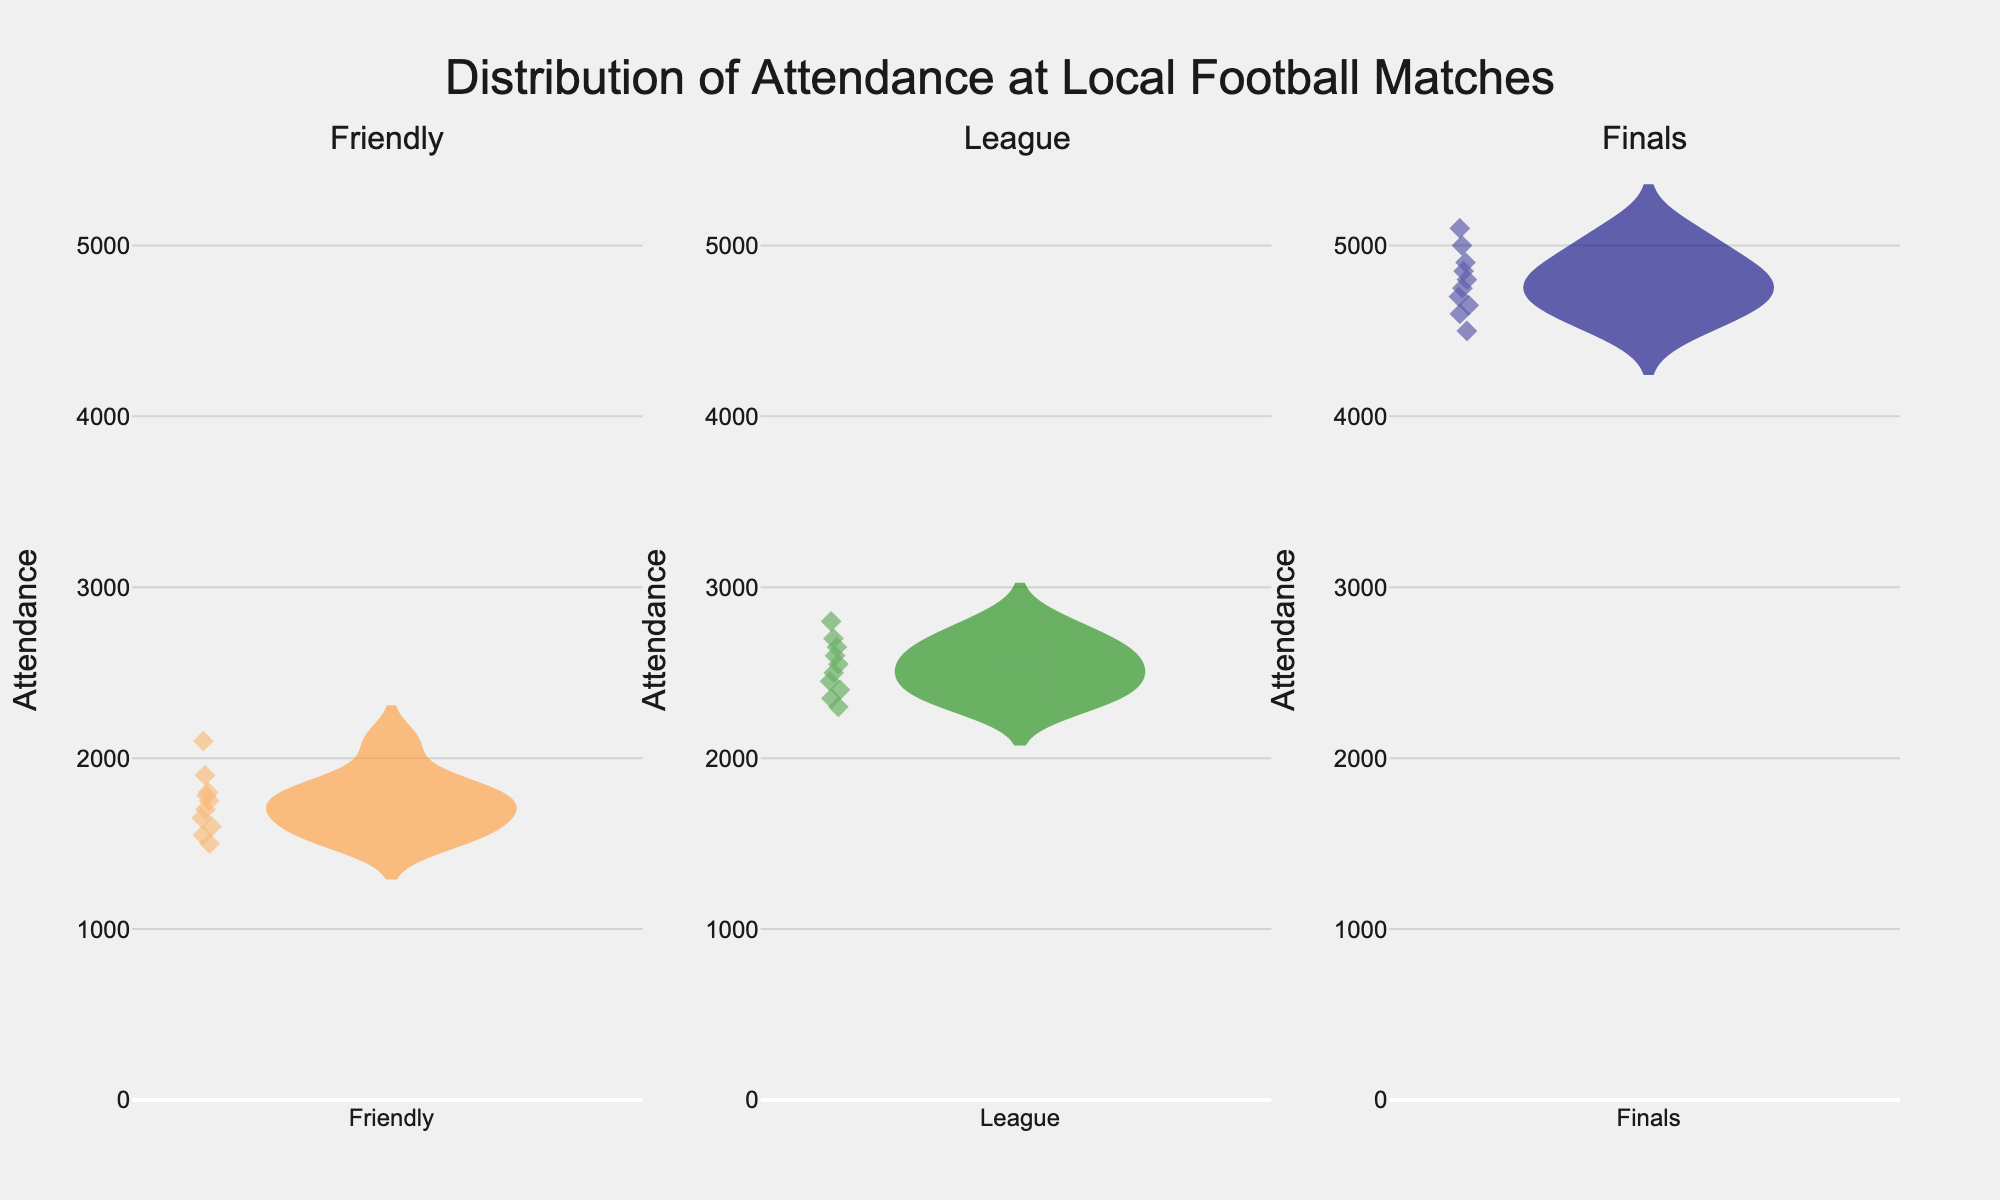What is the overall title of the figure? The overall title is located at the top of the figure.
Answer: Distribution of Attendance at Local Football Matches What are the three types of matches shown in the subplots? The types of matches are indicated by the subplot titles.
Answer: Friendly, League, Finals Which match type has the highest median attendance? The median is displayed as a line in the center of each violin plot. The Finals subplot has the line at the highest value.
Answer: Finals How many attendance data points are shown in the "League" subplot? Count the number of points in the "League" subplot. Each point corresponds to an attendance data entry.
Answer: 10 Which match type has the lowest range of attendance values? The range is the difference between the highest and lowest points in the violin plot. The "Friendly" subplot has the smallest range.
Answer: Friendly What is the approximate maximum attendance shown in the "Friendly" subplot? Look at the highest data point in the "Friendly" subplot.
Answer: 2100 Compare the average attendance of League and Finals matches. Which one is higher? Compare the positions of the mean lines (thicker horizontal line) in both subplots. The Finals subplot is higher.
Answer: Finals What is the color of the plot for the "League" match type? The color can be identified by looking at the fill color of the "League" violin plot.
Answer: Green How does the spread of attendance in "Finals" compare to "Friendly"? Compare the width of the violin plots for each match type. The Finals plot is wider, indicating a larger spread.
Answer: Finals have a larger spread What is the median attendance of the "Friendly" matches? The median is indicated by the horizontal central line in the "Friendly" subplot.
Answer: 1700 